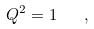<formula> <loc_0><loc_0><loc_500><loc_500>Q ^ { 2 } = 1 \quad ,</formula> 